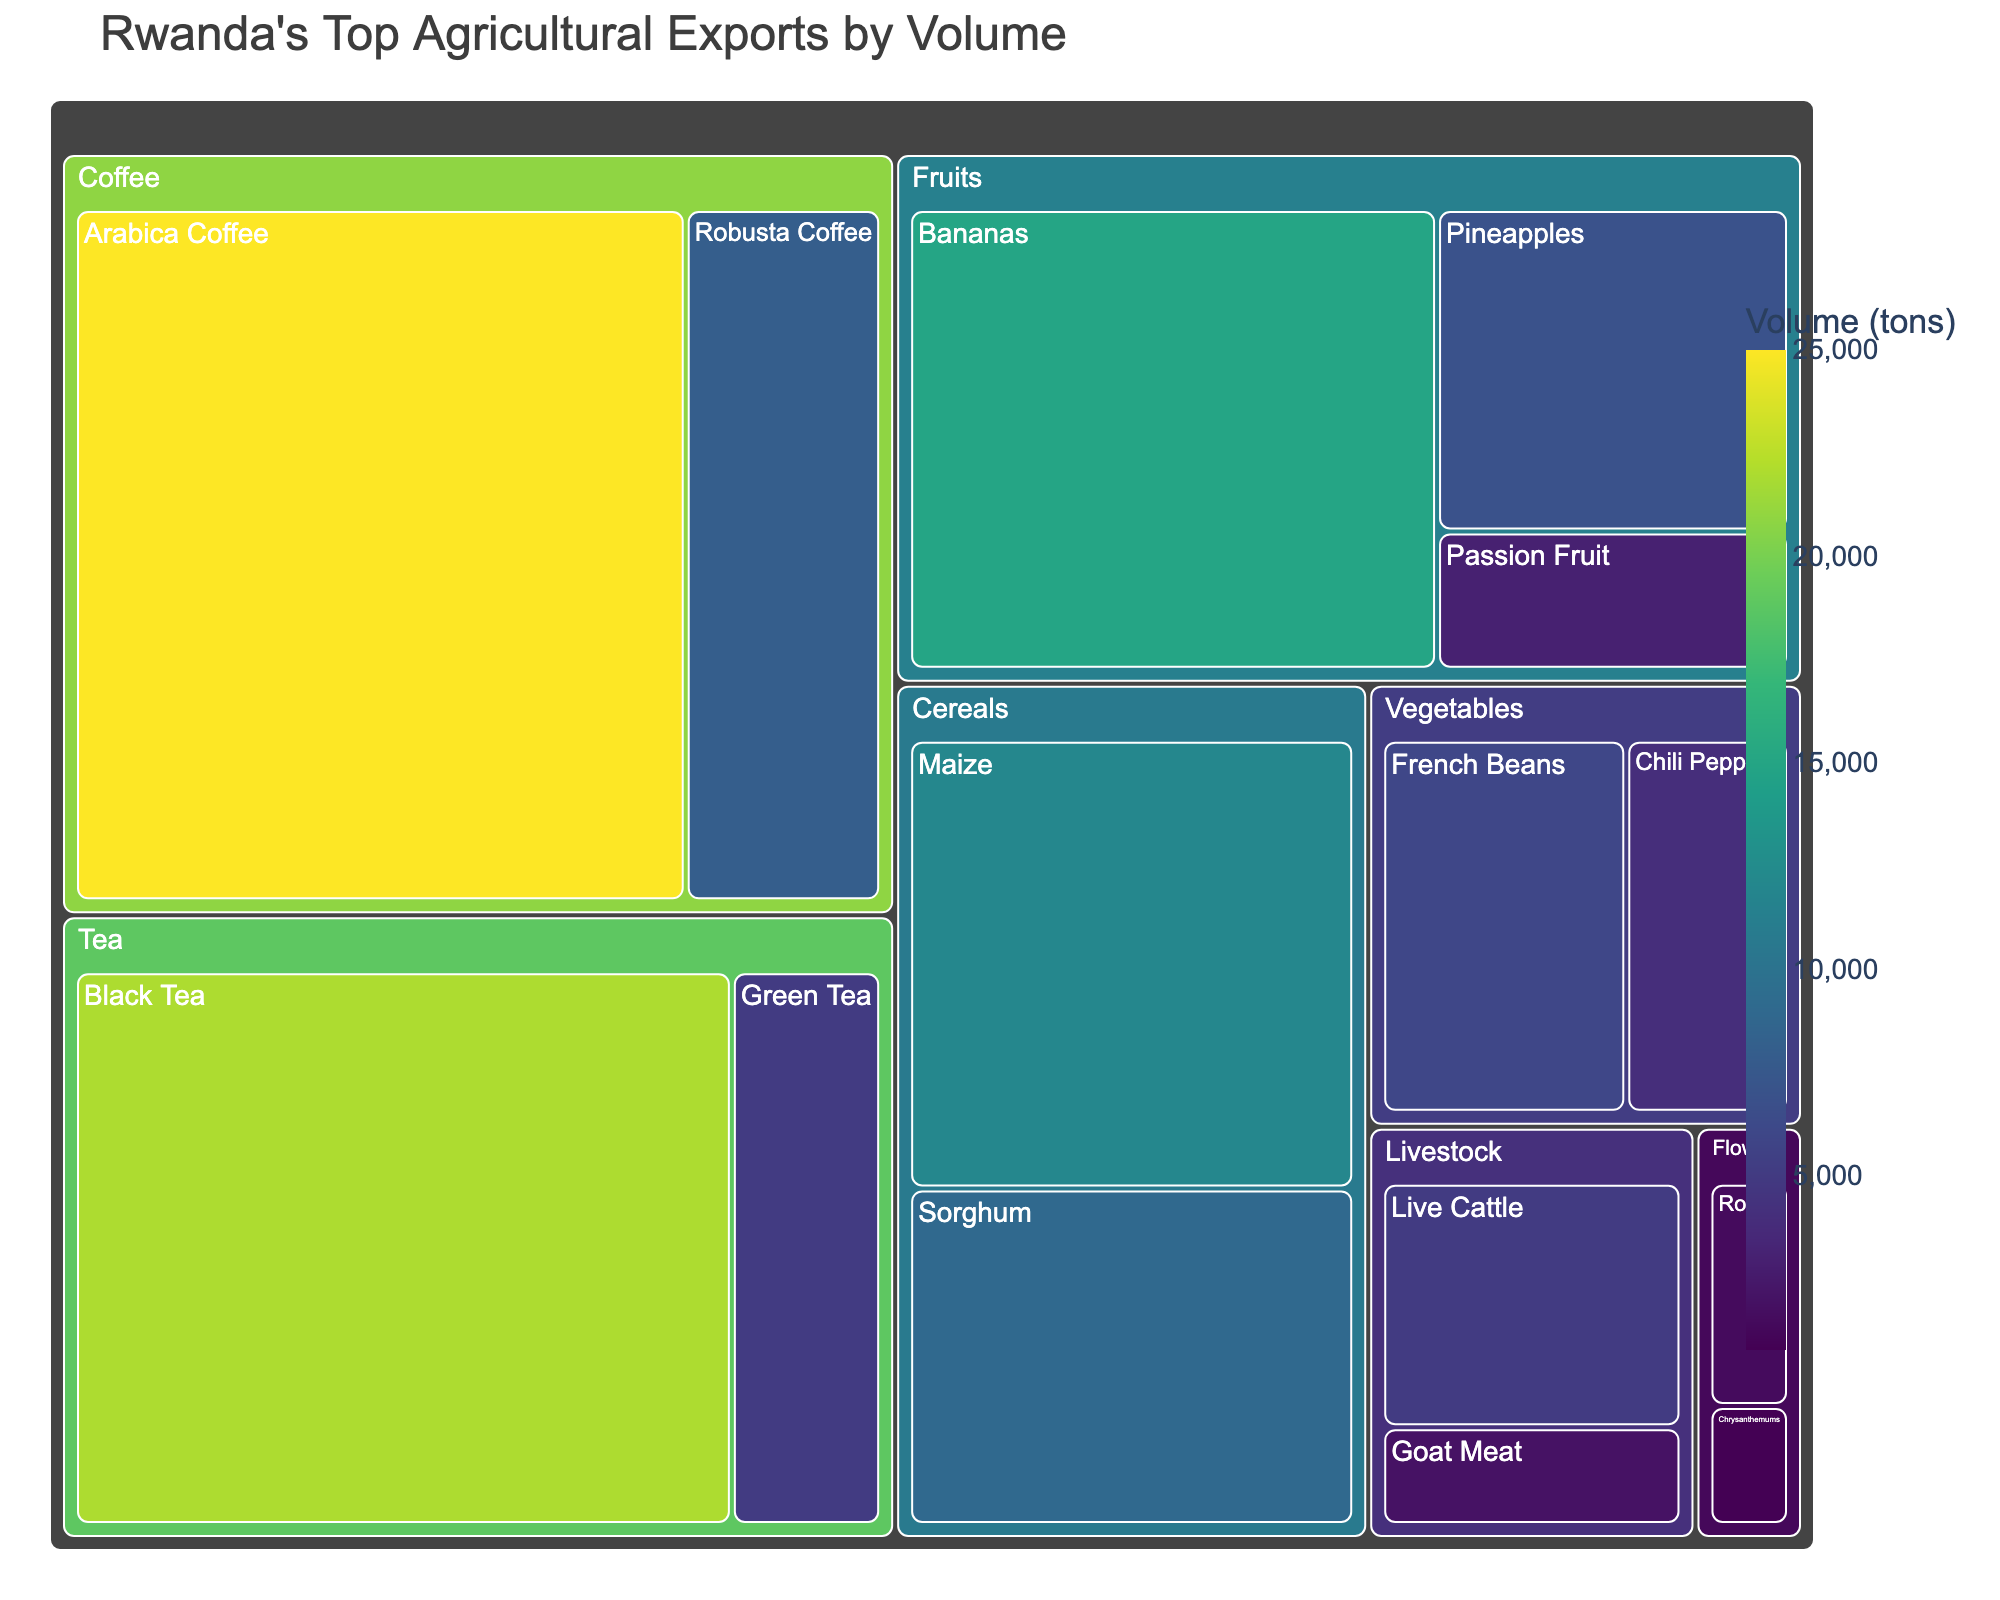what is the title of the treemap? The title is located at the top of the treemap and is typically larger and distinct to catch the viewer's attention. In this case, it's clearly stated as "Rwanda's Top Agricultural Exports by Volume."
Answer: Rwanda's Top Agricultural Exports by Volume Which product category has the highest volume? To determine the category with the highest volume, examine the largest section in the treemap, which is usually the one with the largest area and often the most intense color. The 'Coffee' category stands out as the largest section.
Answer: Coffee What is the combined volume of Arabica Coffee and Robusta Coffee? Sum the volumes of Arabica Coffee and Robusta Coffee. The volumes are 25,000 tons and 8,000 tons respectively. Therefore, 25,000 + 8,000 = 33,000 tons.
Answer: 33,000 tons Which has a larger volume, Bananas or Maize? Compare the areas representing Bananas and Maize in the treemap. Bananas have a volume of 15,000 tons and Maize has 12,000 tons.
Answer: Bananas How much more volume does Black Tea have compared to Green Tea? Subtract the volume of Green Tea from that of Black Tea. Black Tea's volume is 22,000 tons and Green Tea's is 5,000 tons, so 22,000 - 5,000 = 17,000 tons.
Answer: 17,000 tons What is the total volume of all the Fruit products combined? Sum the volumes of Bananas, Pineapples, and Passion Fruit. The volumes are 15,000, 7,000, and 3,000 tons respectively. Therefore, 15,000 + 7,000 + 3,000 = 25,000 tons.
Answer: 25,000 tons Which has the smallest volume, Roses or Chrysanthemums? Compare the sections for Roses and Chrysanthemums. Roses have a volume of 1,500 tons while Chrysanthemums have 800 tons.
Answer: Chrysanthemums What's the average volume of all Livestock products? Sum the volumes of Live Cattle and Goat Meat, then divide by the number of products. The volumes are 5,000 and 2,000 tons respectively. (5,000 + 2,000) / 2 = 3,500 tons.
Answer: 3,500 tons Which categories have a product volume of exactly 4,000 tons? Locate the sections in the treemap indicating a volume of 4,000 tons. Chili Peppers in 'Vegetables' is the product that has this volume.
Answer: Vegetables 